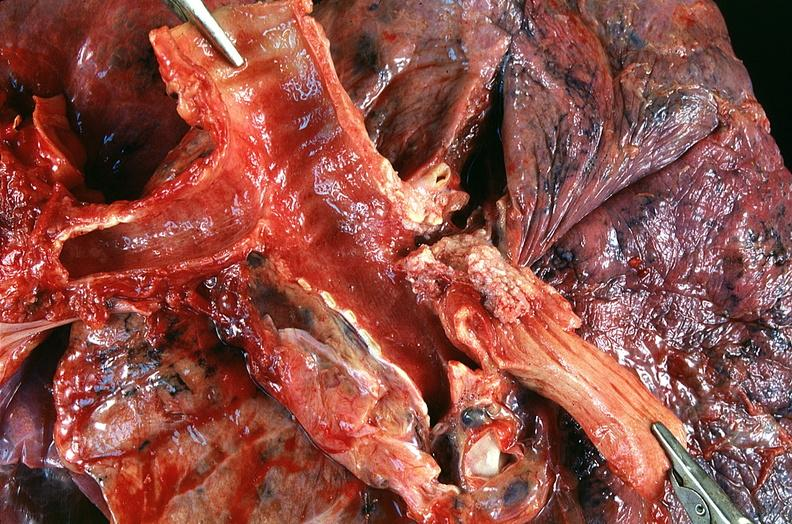what is present?
Answer the question using a single word or phrase. Respiratory 